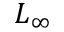<formula> <loc_0><loc_0><loc_500><loc_500>L _ { \infty }</formula> 